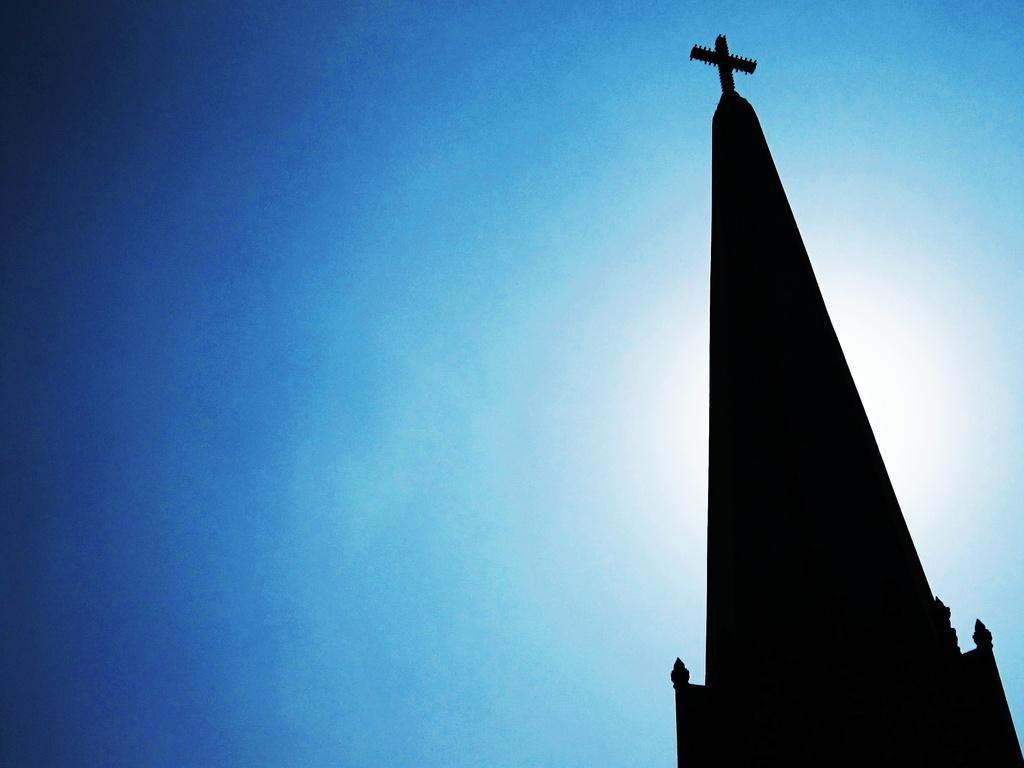What is the main structure in the image? There is a tower in the image. What can be seen in the background of the image? The sky is visible in the image. Can you tell if the image was taken during the day or night? The image may have been taken during the night, as there is no indication of sunlight. What type of print can be seen on the tower in the image? There is no print visible on the tower in the image. How does the death of the tower affect the surrounding landscape? The tower is not dead, and therefore its death does not affect the surrounding landscape. 